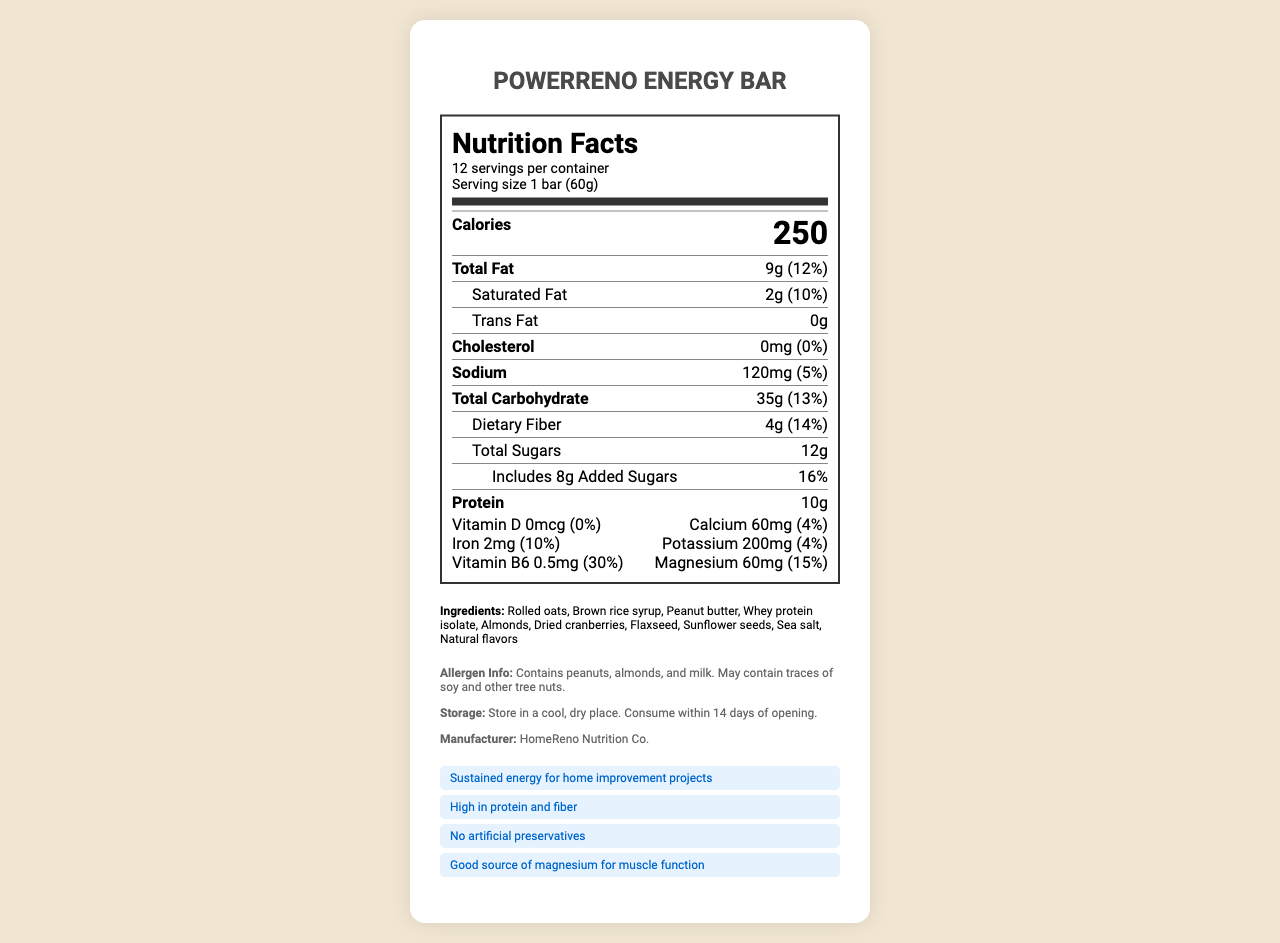How many servings are in one container of PowerReno Energy Bar? The document specifies "12 servings per container" in the nutrition facts section.
Answer: 12 servings What is the protein content in one serving of the PowerReno Energy Bar? The document states that each serving contains 10 grams of protein.
Answer: 10 grams What is the serving size of the PowerReno Energy Bar? The document lists "Serving size 1 bar (60g)" in the nutrition facts section.
Answer: 1 bar (60g) List three main ingredients in the PowerReno Energy Bar? The ingredients section lists these as the first three ingredients.
Answer: Rolled oats, Brown rice syrup, Peanut butter What percentage of daily vitamin B6 does one bar contain? The document states that one serving contains 0.5mg of Vitamin B6, which is 30% of the daily value.
Answer: 30% Which claim is NOT made about the PowerReno Energy Bar?
A. Gluten-free
B. High in protein and fiber
C. Sustained energy for home improvement projects The document lists claims such as "High in protein and fiber" and "Sustained energy for home improvement projects," but does not mention being gluten-free.
Answer: A How much calcium is in one serving? 
I. 2% daily value
II. 4% daily value
III. 6% daily value The document specifies that each serving contains 60mg of calcium, which corresponds to 4% of the daily value.
Answer: II Does the PowerReno Energy Bar contain any artificial preservatives? The product claims include "No artificial preservatives."
Answer: No Summarize the main characteristics of the PowerReno Energy Bar as described in the document. The document highlights the nutritional content, natural ingredient list, product claims, and manufacturer details, emphasizing its benefits for sustained energy and natural composition.
Answer: PowerReno Energy Bar is a high-protein, high-fiber energy bar designed for sustained energy during home improvement projects. It contains natural ingredients like rolled oats, brown rice syrup, peanut butter, whey protein isolate, and almonds. It does not have artificial preservatives and provides essential nutrients like magnesium and Vitamin B6. It is manufactured by HomeReno Nutrition Co. How much sodium does one PowerReno Energy Bar contain per serving? The document states that the sodium content per serving is 120mg.
Answer: 120mg Can this product be consumed by someone with a tree nut allergy? The document's allergen information mentions it contains almonds and may contain traces of other tree nuts.
Answer: No What is the total amount of sugars present in one serving, including added sugars? The document specifies 12g of total sugars and 8g of added sugars.
Answer: 12g of total sugars, 8g of added sugars How long can you store this product once opened? The storage instructions indicate the product should be consumed within 14 days of opening.
Answer: 14 days What is the purpose of magnesium in the PowerReno Energy Bar according to the product claims? The list of product claims mentions that it is a "Good source of magnesium for muscle function."
Answer: Muscle function What is the total fat content in one serving, and what portion of that is saturated fat? The nutrition facts indicate 9g of total fat and 2g of saturated fat per serving.
Answer: 9g total fat, 2g saturated fat Where is the PowerReno Energy Bar manufactured? The manufacturer is listed as HomeReno Nutrition Co.
Answer: HomeReno Nutrition Co. How many grams of dietary fiber are present in one serving of the PowerReno Energy Bar? The document states that each serving contains 4g of dietary fiber.
Answer: 4g Is the PowerReno Energy Bar suitable for vegans? Although the ingredients and allergen information are provided, there is no explicit mention of the product being vegan or containing no animal-derived ingredients.
Answer: Not enough information 